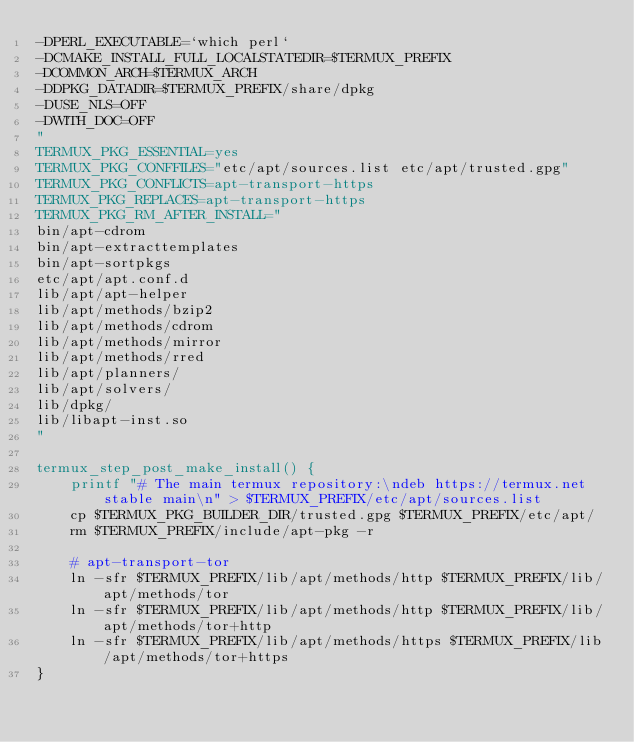Convert code to text. <code><loc_0><loc_0><loc_500><loc_500><_Bash_>-DPERL_EXECUTABLE=`which perl`
-DCMAKE_INSTALL_FULL_LOCALSTATEDIR=$TERMUX_PREFIX
-DCOMMON_ARCH=$TERMUX_ARCH
-DDPKG_DATADIR=$TERMUX_PREFIX/share/dpkg
-DUSE_NLS=OFF
-DWITH_DOC=OFF
"
TERMUX_PKG_ESSENTIAL=yes
TERMUX_PKG_CONFFILES="etc/apt/sources.list etc/apt/trusted.gpg"
TERMUX_PKG_CONFLICTS=apt-transport-https
TERMUX_PKG_REPLACES=apt-transport-https
TERMUX_PKG_RM_AFTER_INSTALL="
bin/apt-cdrom
bin/apt-extracttemplates
bin/apt-sortpkgs
etc/apt/apt.conf.d
lib/apt/apt-helper
lib/apt/methods/bzip2
lib/apt/methods/cdrom
lib/apt/methods/mirror
lib/apt/methods/rred
lib/apt/planners/
lib/apt/solvers/
lib/dpkg/
lib/libapt-inst.so
"

termux_step_post_make_install() {
	printf "# The main termux repository:\ndeb https://termux.net stable main\n" > $TERMUX_PREFIX/etc/apt/sources.list
	cp $TERMUX_PKG_BUILDER_DIR/trusted.gpg $TERMUX_PREFIX/etc/apt/
	rm $TERMUX_PREFIX/include/apt-pkg -r

	# apt-transport-tor
	ln -sfr $TERMUX_PREFIX/lib/apt/methods/http $TERMUX_PREFIX/lib/apt/methods/tor
	ln -sfr $TERMUX_PREFIX/lib/apt/methods/http $TERMUX_PREFIX/lib/apt/methods/tor+http
	ln -sfr $TERMUX_PREFIX/lib/apt/methods/https $TERMUX_PREFIX/lib/apt/methods/tor+https
}
</code> 